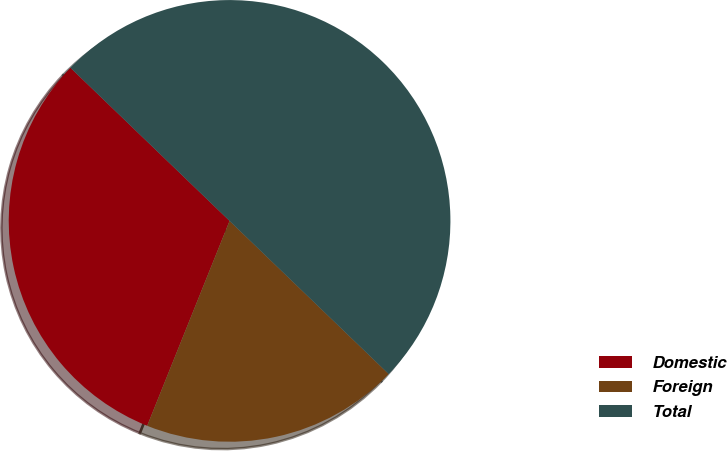Convert chart. <chart><loc_0><loc_0><loc_500><loc_500><pie_chart><fcel>Domestic<fcel>Foreign<fcel>Total<nl><fcel>31.11%<fcel>18.89%<fcel>50.0%<nl></chart> 